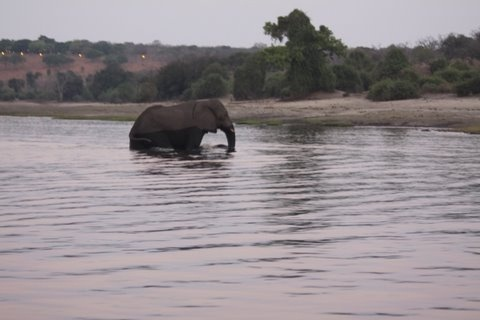Describe the objects in this image and their specific colors. I can see a elephant in darkgray, black, and gray tones in this image. 